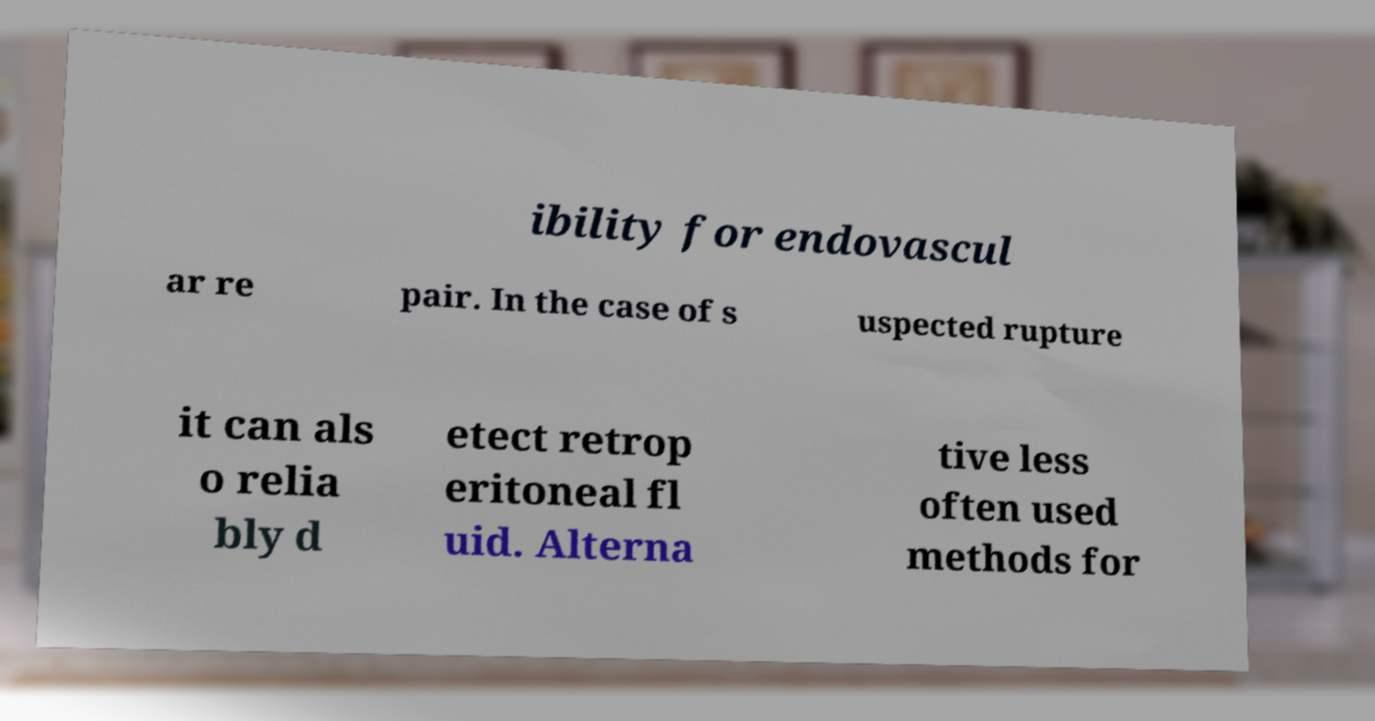Can you read and provide the text displayed in the image?This photo seems to have some interesting text. Can you extract and type it out for me? ibility for endovascul ar re pair. In the case of s uspected rupture it can als o relia bly d etect retrop eritoneal fl uid. Alterna tive less often used methods for 